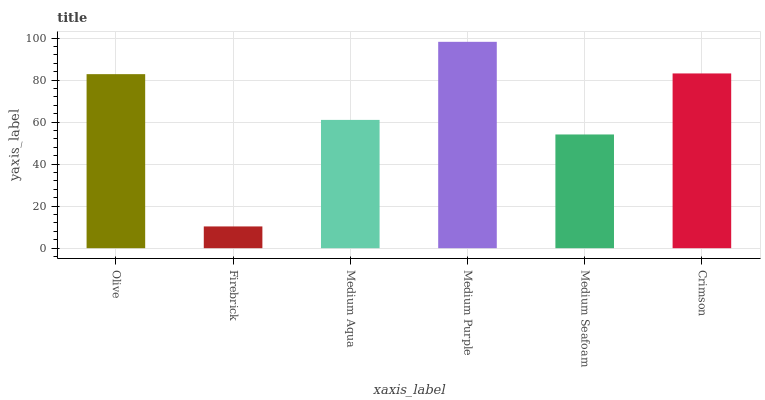Is Medium Aqua the minimum?
Answer yes or no. No. Is Medium Aqua the maximum?
Answer yes or no. No. Is Medium Aqua greater than Firebrick?
Answer yes or no. Yes. Is Firebrick less than Medium Aqua?
Answer yes or no. Yes. Is Firebrick greater than Medium Aqua?
Answer yes or no. No. Is Medium Aqua less than Firebrick?
Answer yes or no. No. Is Olive the high median?
Answer yes or no. Yes. Is Medium Aqua the low median?
Answer yes or no. Yes. Is Medium Seafoam the high median?
Answer yes or no. No. Is Medium Purple the low median?
Answer yes or no. No. 